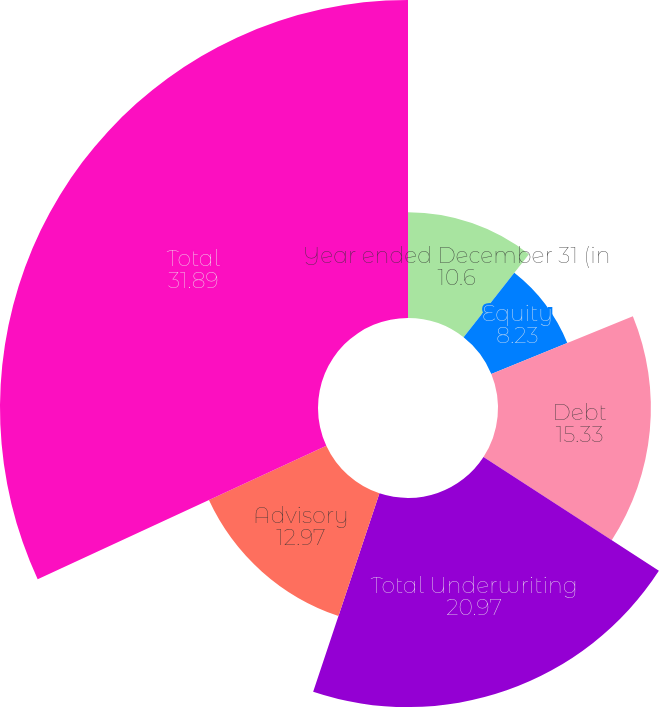Convert chart to OTSL. <chart><loc_0><loc_0><loc_500><loc_500><pie_chart><fcel>Year ended December 31 (in<fcel>Equity<fcel>Debt<fcel>Total Underwriting<fcel>Advisory<fcel>Total<nl><fcel>10.6%<fcel>8.23%<fcel>15.33%<fcel>20.97%<fcel>12.97%<fcel>31.89%<nl></chart> 